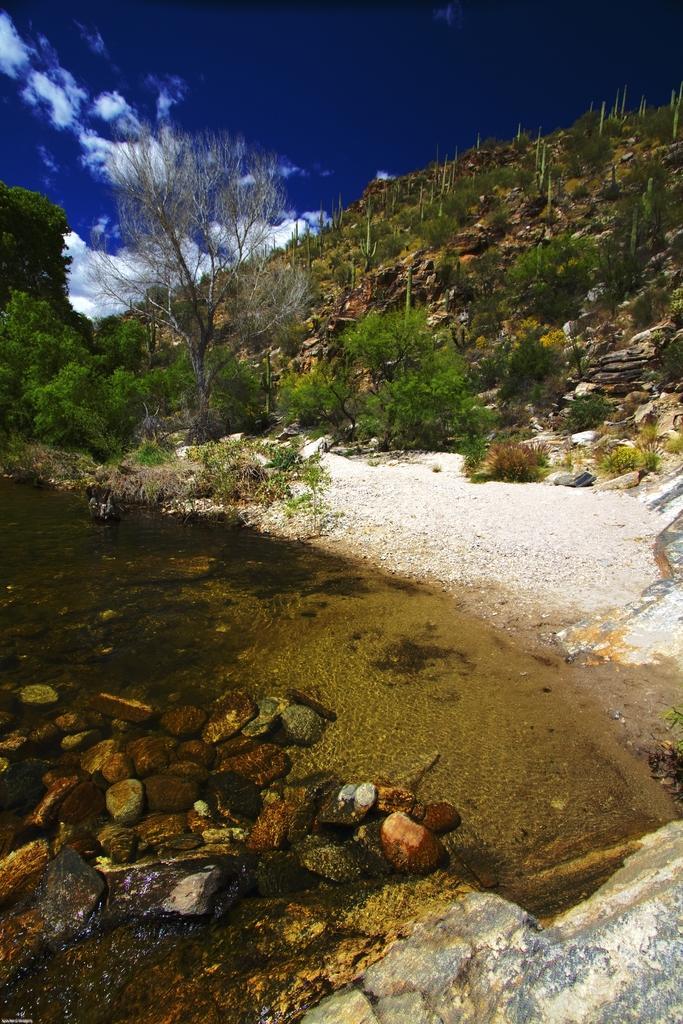In one or two sentences, can you explain what this image depicts? In this image we can see mountains with trees. At the bottom of the image there are stones. At the top of the image there is sky and clouds. 